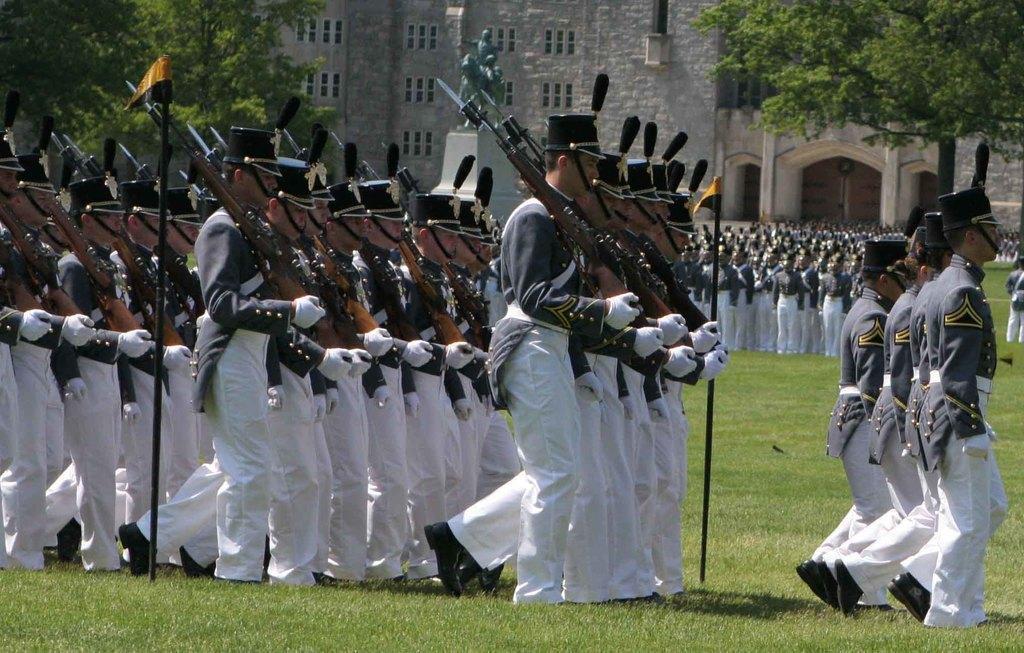How would you summarize this image in a sentence or two? In the center of the image we can see a few people are walking and they are wearing caps. And we can see a few people are holding guns and they are in different costumes. And we can see the grass, poles and golden color small flags. In the background there is a building, windows, pillars, trees, grass, few people are standing, few people are wearing caps, few people are holding some objects and a few other objects. 